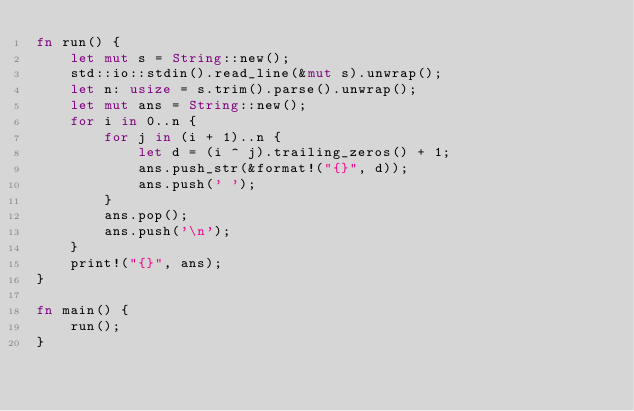<code> <loc_0><loc_0><loc_500><loc_500><_Rust_>fn run() {
    let mut s = String::new();
    std::io::stdin().read_line(&mut s).unwrap();
    let n: usize = s.trim().parse().unwrap();
    let mut ans = String::new();
    for i in 0..n {
        for j in (i + 1)..n {
            let d = (i ^ j).trailing_zeros() + 1;
            ans.push_str(&format!("{}", d));
            ans.push(' ');
        }
        ans.pop();
        ans.push('\n');
    }
    print!("{}", ans);
}

fn main() {
    run();
}
</code> 